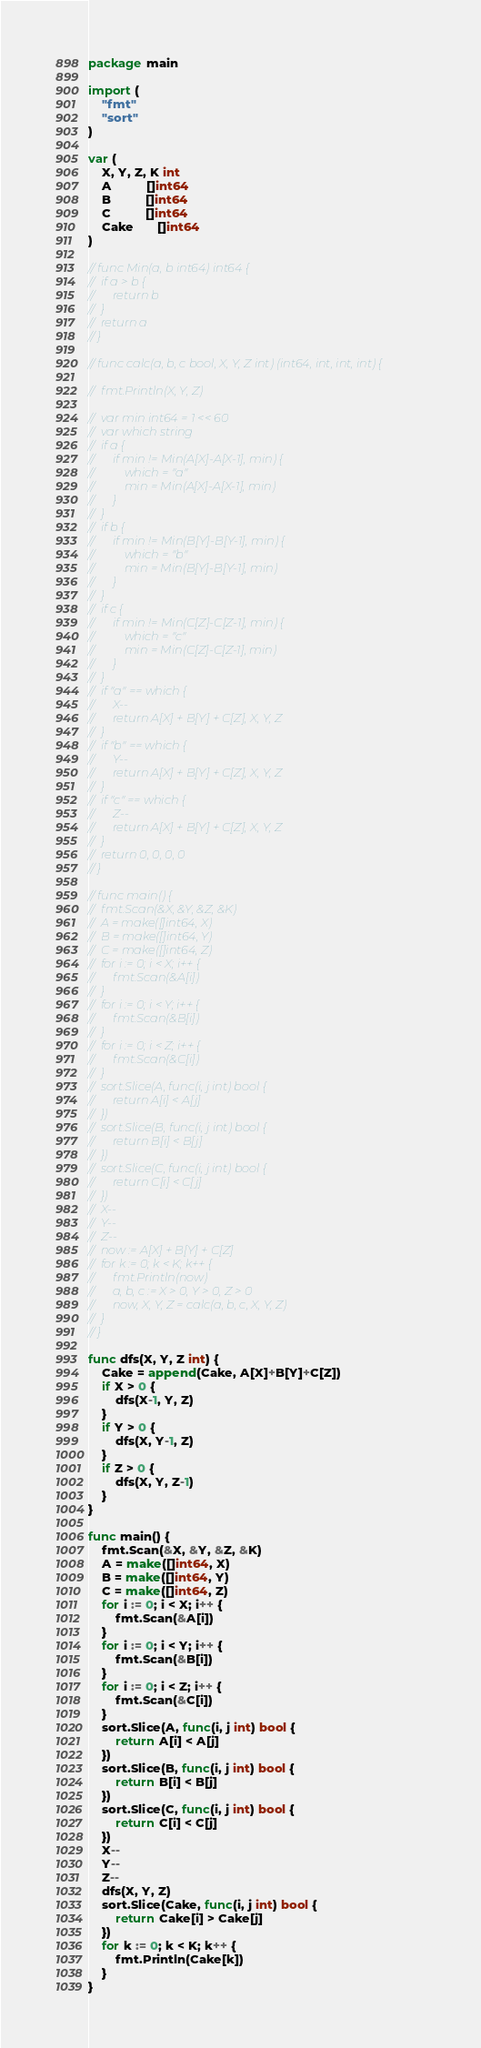<code> <loc_0><loc_0><loc_500><loc_500><_Go_>package main

import (
	"fmt"
	"sort"
)

var (
	X, Y, Z, K int
	A          []int64
	B          []int64
	C          []int64
	Cake       []int64
)

// func Min(a, b int64) int64 {
// 	if a > b {
// 		return b
// 	}
// 	return a
// }

// func calc(a, b, c bool, X, Y, Z int) (int64, int, int, int) {

// 	fmt.Println(X, Y, Z)

// 	var min int64 = 1 << 60
// 	var which string
// 	if a {
// 		if min != Min(A[X]-A[X-1], min) {
// 			which = "a"
// 			min = Min(A[X]-A[X-1], min)
// 		}
// 	}
// 	if b {
// 		if min != Min(B[Y]-B[Y-1], min) {
// 			which = "b"
// 			min = Min(B[Y]-B[Y-1], min)
// 		}
// 	}
// 	if c {
// 		if min != Min(C[Z]-C[Z-1], min) {
// 			which = "c"
// 			min = Min(C[Z]-C[Z-1], min)
// 		}
// 	}
// 	if "a" == which {
// 		X--
// 		return A[X] + B[Y] + C[Z], X, Y, Z
// 	}
// 	if "b" == which {
// 		Y--
// 		return A[X] + B[Y] + C[Z], X, Y, Z
// 	}
// 	if "c" == which {
// 		Z--
// 		return A[X] + B[Y] + C[Z], X, Y, Z
// 	}
// 	return 0, 0, 0, 0
// }

// func main() {
// 	fmt.Scan(&X, &Y, &Z, &K)
// 	A = make([]int64, X)
// 	B = make([]int64, Y)
// 	C = make([]int64, Z)
// 	for i := 0; i < X; i++ {
// 		fmt.Scan(&A[i])
// 	}
// 	for i := 0; i < Y; i++ {
// 		fmt.Scan(&B[i])
// 	}
// 	for i := 0; i < Z; i++ {
// 		fmt.Scan(&C[i])
// 	}
// 	sort.Slice(A, func(i, j int) bool {
// 		return A[i] < A[j]
// 	})
// 	sort.Slice(B, func(i, j int) bool {
// 		return B[i] < B[j]
// 	})
// 	sort.Slice(C, func(i, j int) bool {
// 		return C[i] < C[j]
// 	})
// 	X--
// 	Y--
// 	Z--
// 	now := A[X] + B[Y] + C[Z]
// 	for k := 0; k < K; k++ {
// 		fmt.Println(now)
// 		a, b, c := X > 0, Y > 0, Z > 0
// 		now, X, Y, Z = calc(a, b, c, X, Y, Z)
// 	}
// }

func dfs(X, Y, Z int) {
	Cake = append(Cake, A[X]+B[Y]+C[Z])
	if X > 0 {
		dfs(X-1, Y, Z)
	}
	if Y > 0 {
		dfs(X, Y-1, Z)
	}
	if Z > 0 {
		dfs(X, Y, Z-1)
	}
}

func main() {
	fmt.Scan(&X, &Y, &Z, &K)
	A = make([]int64, X)
	B = make([]int64, Y)
	C = make([]int64, Z)
	for i := 0; i < X; i++ {
		fmt.Scan(&A[i])
	}
	for i := 0; i < Y; i++ {
		fmt.Scan(&B[i])
	}
	for i := 0; i < Z; i++ {
		fmt.Scan(&C[i])
	}
	sort.Slice(A, func(i, j int) bool {
		return A[i] < A[j]
	})
	sort.Slice(B, func(i, j int) bool {
		return B[i] < B[j]
	})
	sort.Slice(C, func(i, j int) bool {
		return C[i] < C[j]
	})
	X--
	Y--
	Z--
	dfs(X, Y, Z)
	sort.Slice(Cake, func(i, j int) bool {
		return Cake[i] > Cake[j]
	})
	for k := 0; k < K; k++ {
		fmt.Println(Cake[k])
	}
}
</code> 